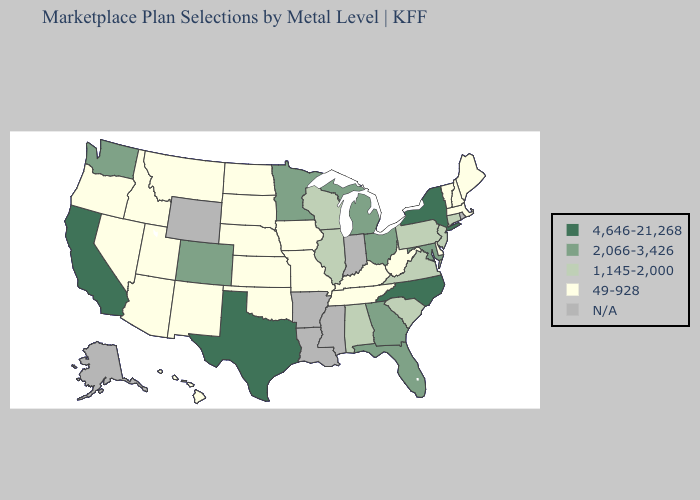Name the states that have a value in the range 4,646-21,268?
Short answer required. California, New York, North Carolina, Texas. Does Texas have the highest value in the USA?
Short answer required. Yes. What is the highest value in states that border Wyoming?
Short answer required. 2,066-3,426. What is the highest value in the West ?
Answer briefly. 4,646-21,268. Name the states that have a value in the range 49-928?
Short answer required. Arizona, Delaware, Hawaii, Idaho, Iowa, Kansas, Kentucky, Maine, Massachusetts, Missouri, Montana, Nebraska, Nevada, New Hampshire, New Mexico, North Dakota, Oklahoma, Oregon, South Dakota, Tennessee, Utah, Vermont, West Virginia. Among the states that border Florida , which have the lowest value?
Write a very short answer. Alabama. What is the value of Arizona?
Write a very short answer. 49-928. Which states hav the highest value in the MidWest?
Concise answer only. Michigan, Minnesota, Ohio. Name the states that have a value in the range 1,145-2,000?
Quick response, please. Alabama, Connecticut, Illinois, New Jersey, Pennsylvania, South Carolina, Virginia, Wisconsin. Which states have the lowest value in the South?
Keep it brief. Delaware, Kentucky, Oklahoma, Tennessee, West Virginia. Does Texas have the highest value in the USA?
Write a very short answer. Yes. What is the highest value in the USA?
Keep it brief. 4,646-21,268. Name the states that have a value in the range 1,145-2,000?
Short answer required. Alabama, Connecticut, Illinois, New Jersey, Pennsylvania, South Carolina, Virginia, Wisconsin. Does the first symbol in the legend represent the smallest category?
Answer briefly. No. 